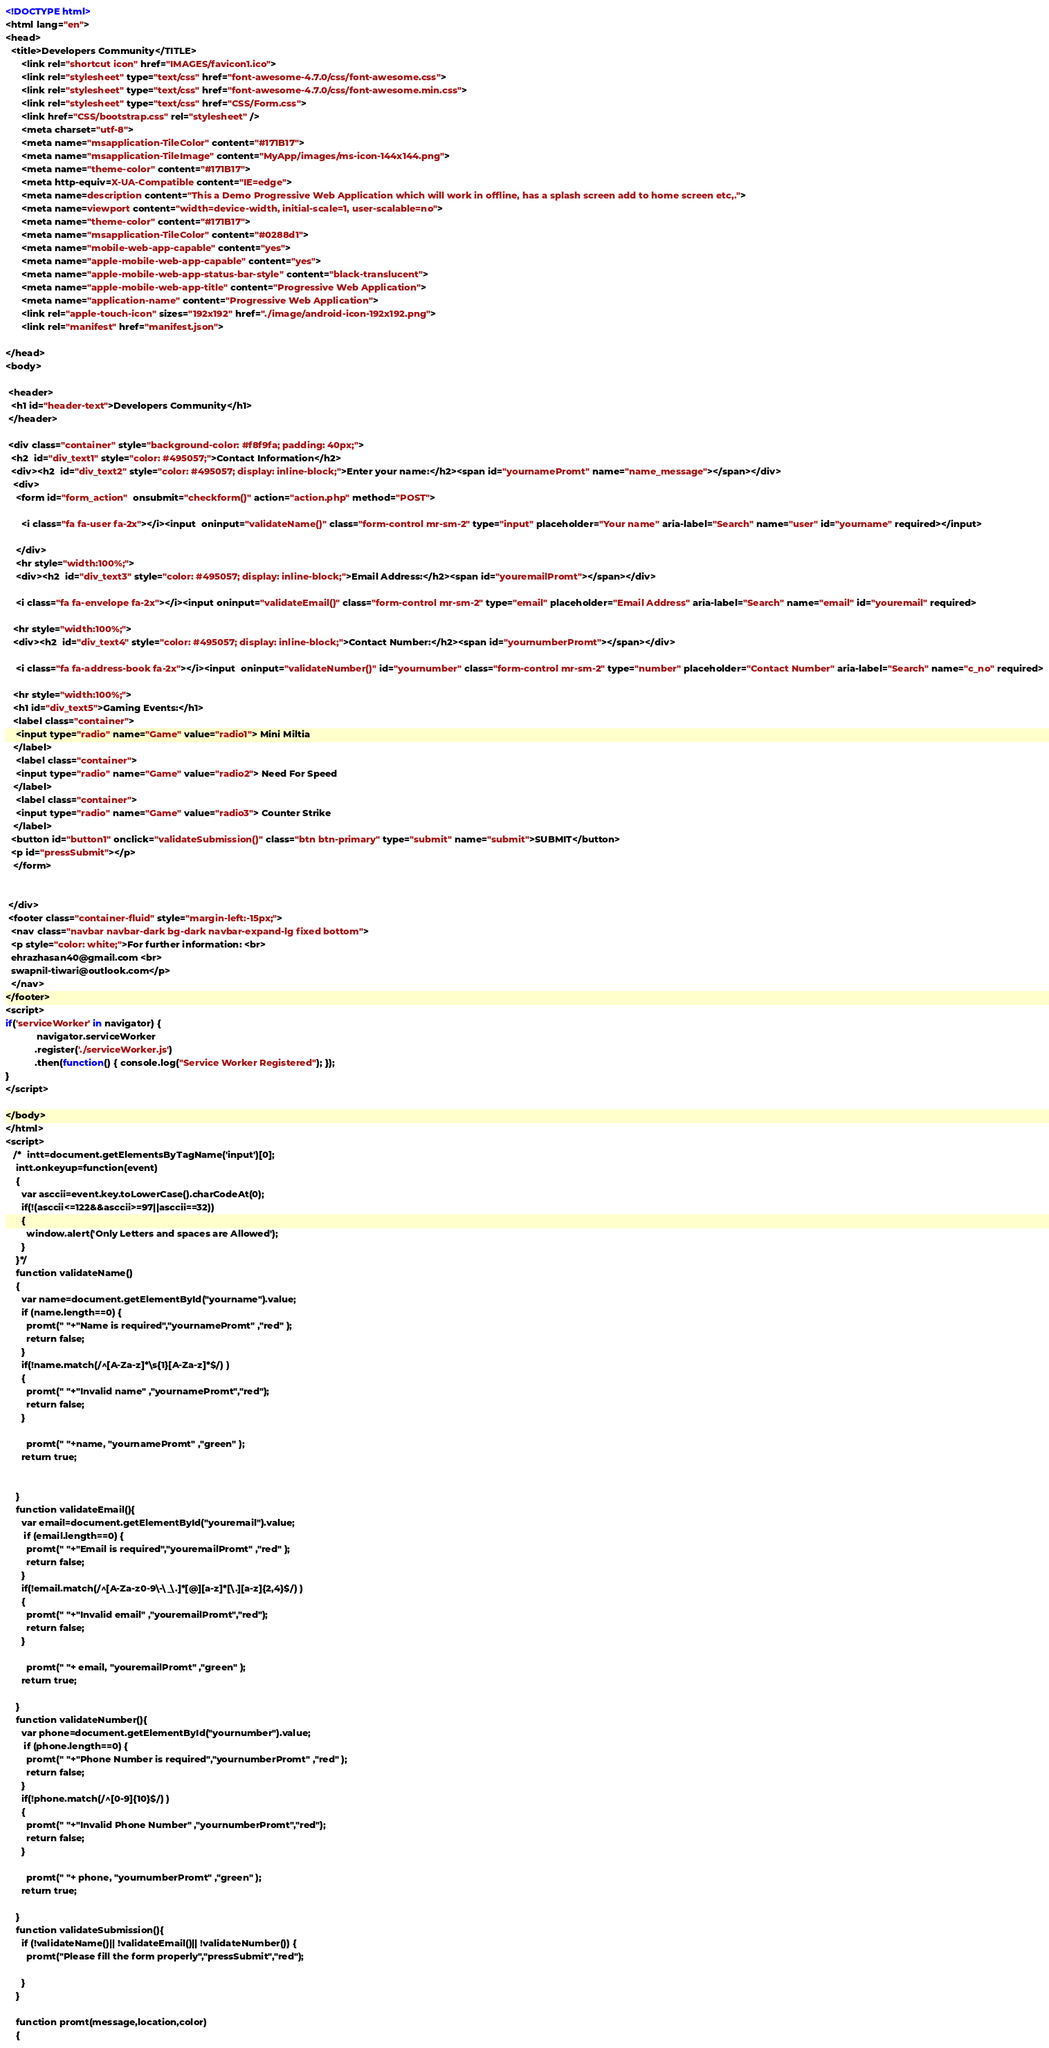<code> <loc_0><loc_0><loc_500><loc_500><_HTML_><!DOCTYPE html>
<html lang="en">
<head>
  <title>Developers Community</TITLE>
      <link rel="shortcut icon" href="IMAGES/favicon1.ico">
      <link rel="stylesheet" type="text/css" href="font-awesome-4.7.0/css/font-awesome.css">
      <link rel="stylesheet" type="text/css" href="font-awesome-4.7.0/css/font-awesome.min.css">
      <link rel="stylesheet" type="text/css" href="CSS/Form.css">
      <link href="CSS/bootstrap.css" rel="stylesheet" />
      <meta charset="utf-8">
      <meta name="msapplication-TileColor" content="#171B17">
      <meta name="msapplication-TileImage" content="MyApp/images/ms-icon-144x144.png">
      <meta name="theme-color" content="#171B17">
      <meta http-equiv=X-UA-Compatible content="IE=edge">
      <meta name=description content="This a Demo Progressive Web Application which will work in offline, has a splash screen add to home screen etc,.">
      <meta name=viewport content="width=device-width, initial-scale=1, user-scalable=no">
      <meta name="theme-color" content="#171B17">
      <meta name="msapplication-TileColor" content="#0288d1">
      <meta name="mobile-web-app-capable" content="yes">
      <meta name="apple-mobile-web-app-capable" content="yes">
      <meta name="apple-mobile-web-app-status-bar-style" content="black-translucent">
      <meta name="apple-mobile-web-app-title" content="Progressive Web Application">
      <meta name="application-name" content="Progressive Web Application">
      <link rel="apple-touch-icon" sizes="192x192" href="./image/android-icon-192x192.png">
      <link rel="manifest" href="manifest.json">
      
</head>
<body>

 <header>
  <h1 id="header-text">Developers Community</h1>
 </header>
 
 <div class="container" style="background-color: #f8f9fa; padding: 40px;">
  <h2  id="div_text1" style="color: #495057;">Contact Information</h2>
  <div><h2  id="div_text2" style="color: #495057; display: inline-block;">Enter your name:</h2><span id="yournamePromt" name="name_message"></span></div>
   <div>
    <form id="form_action"  onsubmit="checkform()" action="action.php" method="POST">
   
      <i class="fa fa-user fa-2x"></i><input  oninput="validateName()" class="form-control mr-sm-2" type="input" placeholder="Your name" aria-label="Search" name="user" id="yourname" required></input>
   
    </div>
    <hr style="width:100%;">
    <div><h2  id="div_text3" style="color: #495057; display: inline-block;">Email Address:</h2><span id="youremailPromt"></span></div>
   
    <i class="fa fa-envelope fa-2x"></i><input oninput="validateEmail()" class="form-control mr-sm-2" type="email" placeholder="Email Address" aria-label="Search" name="email" id="youremail" required>
   
   <hr style="width:100%;">
   <div><h2  id="div_text4" style="color: #495057; display: inline-block;">Contact Number:</h2><span id="yournumberPromt"></span></div>
   
    <i class="fa fa-address-book fa-2x"></i><input  oninput="validateNumber()" id="yournumber" class="form-control mr-sm-2" type="number" placeholder="Contact Number" aria-label="Search" name="c_no" required>

   <hr style="width:100%;">
   <h1 id="div_text5">Gaming Events:</h1>
   <label class="container"> 
    <input type="radio" name="Game" value="radio1"> Mini Miltia
   </label>   
    <label class="container"> 
    <input type="radio" name="Game" value="radio2"> Need For Speed
   </label>   
    <label class="container"> 
    <input type="radio" name="Game" value="radio3"> Counter Strike
   </label>
  <button id="button1" onclick="validateSubmission()" class="btn btn-primary" type="submit" name="submit">SUBMIT</button> 
  <p id="pressSubmit"></p>
   </form> 
     
      
 </div>
 <footer class="container-fluid" style="margin-left:-15px;">
  <nav class="navbar navbar-dark bg-dark navbar-expand-lg fixed bottom">
  <p style="color: white;">For further information: <br>
  ehrazhasan40@gmail.com <br>
  swapnil-tiwari@outlook.com</p>
  </nav>
</footer>
<script>
if('serviceWorker' in navigator) {
            navigator.serviceWorker
           .register('./serviceWorker.js')
           .then(function() { console.log("Service Worker Registered"); });
}
</script>

</body>
</html>
<script>
   /*  intt=document.getElementsByTagName('input')[0];
    intt.onkeyup=function(event)
    {
      var asccii=event.key.toLowerCase().charCodeAt(0);
      if(!(asccii<=122&&asccii>=97||asccii==32))
      {
        window.alert('Only Letters and spaces are Allowed');
      }
    }*/
    function validateName()
    {
      var name=document.getElementById("yourname").value;
      if (name.length==0) {
        promt(" "+"Name is required","yournamePromt" ,"red" );
        return false;
      } 
      if(!name.match(/^[A-Za-z]*\s{1}[A-Za-z]*$/) )
      {
        promt(" "+"Invalid name" ,"yournamePromt","red");
        return false;
      }
      
        promt(" "+name, "yournamePromt" ,"green" );
      return true;
      
      
    }
    function validateEmail(){
      var email=document.getElementById("youremail").value;
       if (email.length==0) {
        promt(" "+"Email is required","youremailPromt" ,"red" );
        return false;
      } 
      if(!email.match(/^[A-Za-z0-9\-\_\.]*[@][a-z]*[\.][a-z]{2,4}$/) )
      {
        promt(" "+"Invalid email" ,"youremailPromt","red");
        return false;
      }
      
        promt(" "+ email, "youremailPromt" ,"green" );
      return true;

    }
    function validateNumber(){
      var phone=document.getElementById("yournumber").value;
       if (phone.length==0) {
        promt(" "+"Phone Number is required","yournumberPromt" ,"red" );
        return false;
      } 
      if(!phone.match(/^[0-9]{10}$/) )
      {
        promt(" "+"Invalid Phone Number" ,"yournumberPromt","red");
        return false;
      }
      
        promt(" "+ phone, "yournumberPromt" ,"green" );
      return true;

    }
    function validateSubmission(){
      if (!validateName()|| !validateEmail()|| !validateNumber()) {
        promt("Please fill the form properly","pressSubmit","red");

      }
    }

    function promt(message,location,color) 
    {</code> 